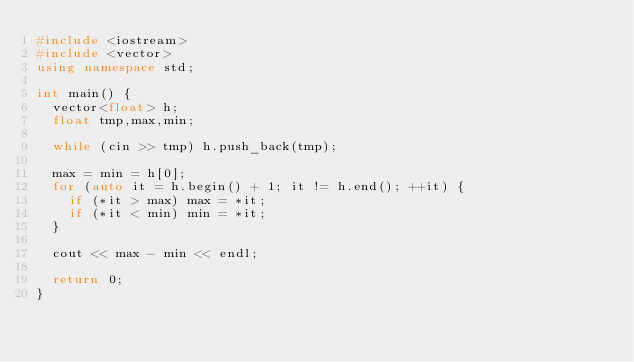Convert code to text. <code><loc_0><loc_0><loc_500><loc_500><_C++_>#include <iostream>
#include <vector>
using namespace std;

int main() {
	vector<float> h;
	float tmp,max,min;

	while (cin >> tmp) h.push_back(tmp);

	max = min = h[0];
	for (auto it = h.begin() + 1; it != h.end(); ++it) {
		if (*it > max) max = *it;
		if (*it < min) min = *it;
	}

	cout << max - min << endl;
	
	return 0;
}</code> 